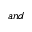Convert formula to latex. <formula><loc_0><loc_0><loc_500><loc_500>a n d</formula> 